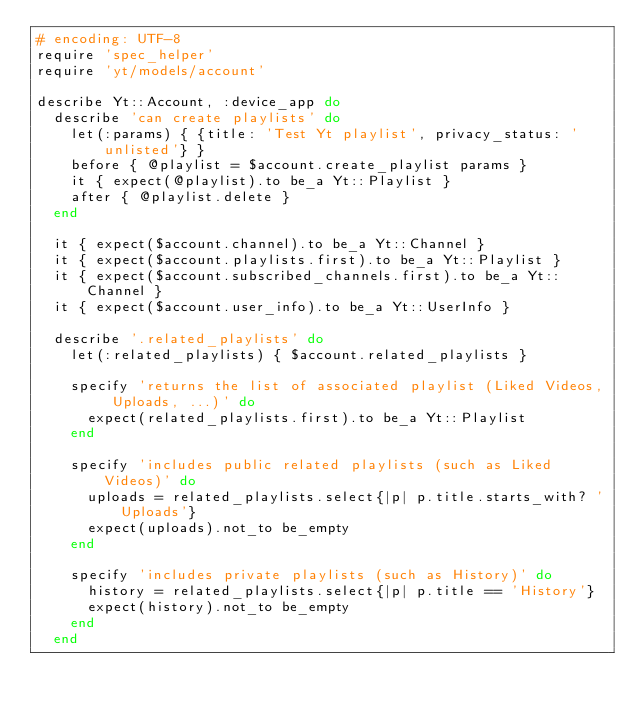Convert code to text. <code><loc_0><loc_0><loc_500><loc_500><_Ruby_># encoding: UTF-8
require 'spec_helper'
require 'yt/models/account'

describe Yt::Account, :device_app do
  describe 'can create playlists' do
    let(:params) { {title: 'Test Yt playlist', privacy_status: 'unlisted'} }
    before { @playlist = $account.create_playlist params }
    it { expect(@playlist).to be_a Yt::Playlist }
    after { @playlist.delete }
  end

  it { expect($account.channel).to be_a Yt::Channel }
  it { expect($account.playlists.first).to be_a Yt::Playlist }
  it { expect($account.subscribed_channels.first).to be_a Yt::Channel }
  it { expect($account.user_info).to be_a Yt::UserInfo }

  describe '.related_playlists' do
    let(:related_playlists) { $account.related_playlists }

    specify 'returns the list of associated playlist (Liked Videos, Uploads, ...)' do
      expect(related_playlists.first).to be_a Yt::Playlist
    end

    specify 'includes public related playlists (such as Liked Videos)' do
      uploads = related_playlists.select{|p| p.title.starts_with? 'Uploads'}
      expect(uploads).not_to be_empty
    end

    specify 'includes private playlists (such as History)' do
      history = related_playlists.select{|p| p.title == 'History'}
      expect(history).not_to be_empty
    end
  end
</code> 